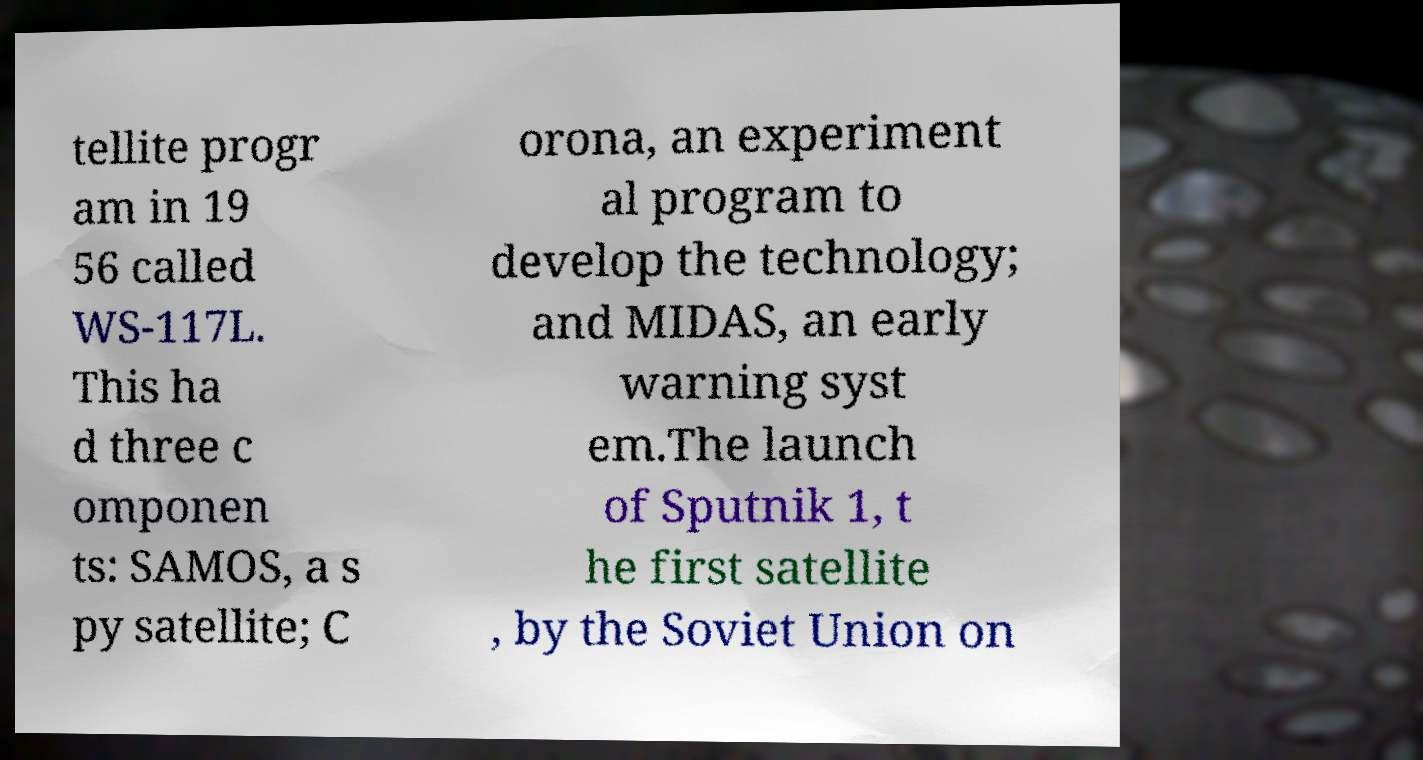Please identify and transcribe the text found in this image. tellite progr am in 19 56 called WS-117L. This ha d three c omponen ts: SAMOS, a s py satellite; C orona, an experiment al program to develop the technology; and MIDAS, an early warning syst em.The launch of Sputnik 1, t he first satellite , by the Soviet Union on 